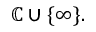Convert formula to latex. <formula><loc_0><loc_0><loc_500><loc_500>\mathbb { C } \cup \{ \infty \} .</formula> 